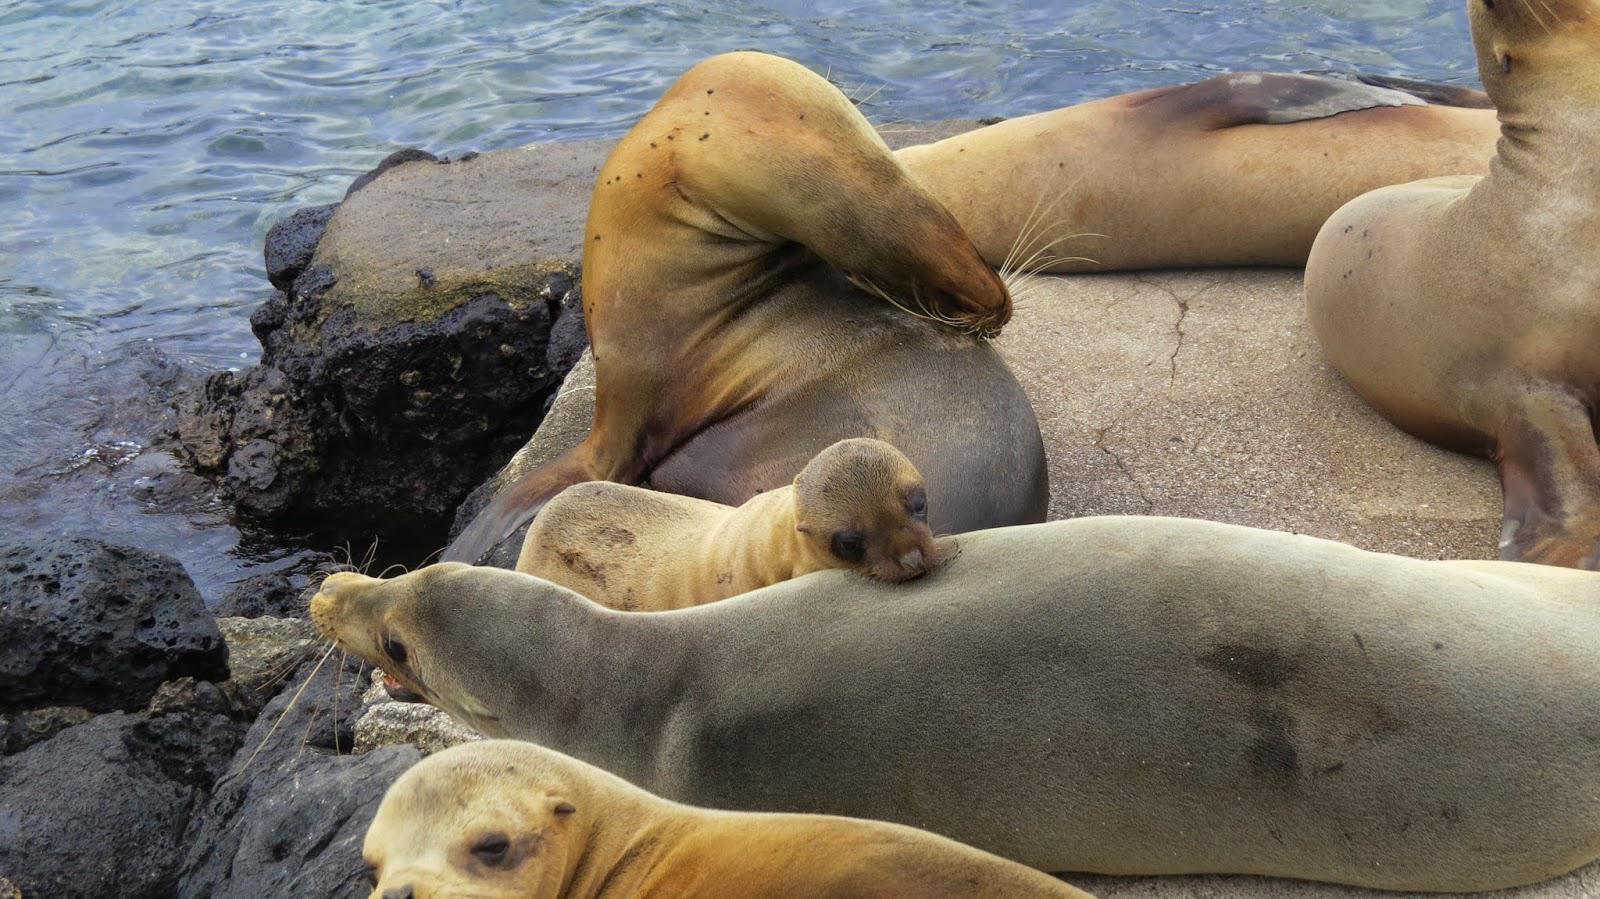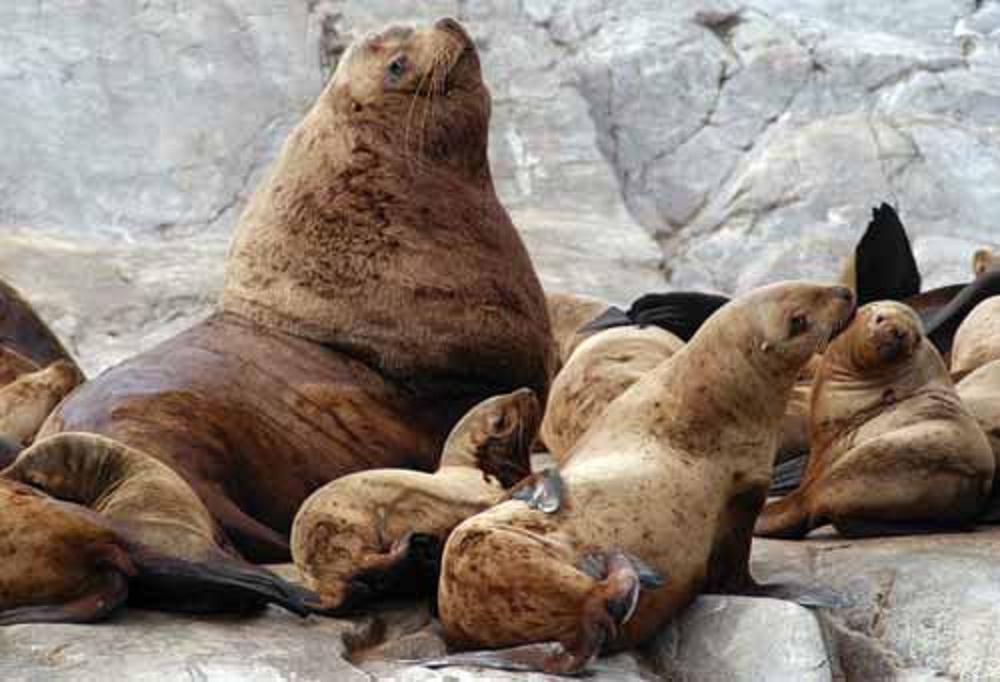The first image is the image on the left, the second image is the image on the right. For the images displayed, is the sentence "There is water in the image on the left." factually correct? Answer yes or no. Yes. 